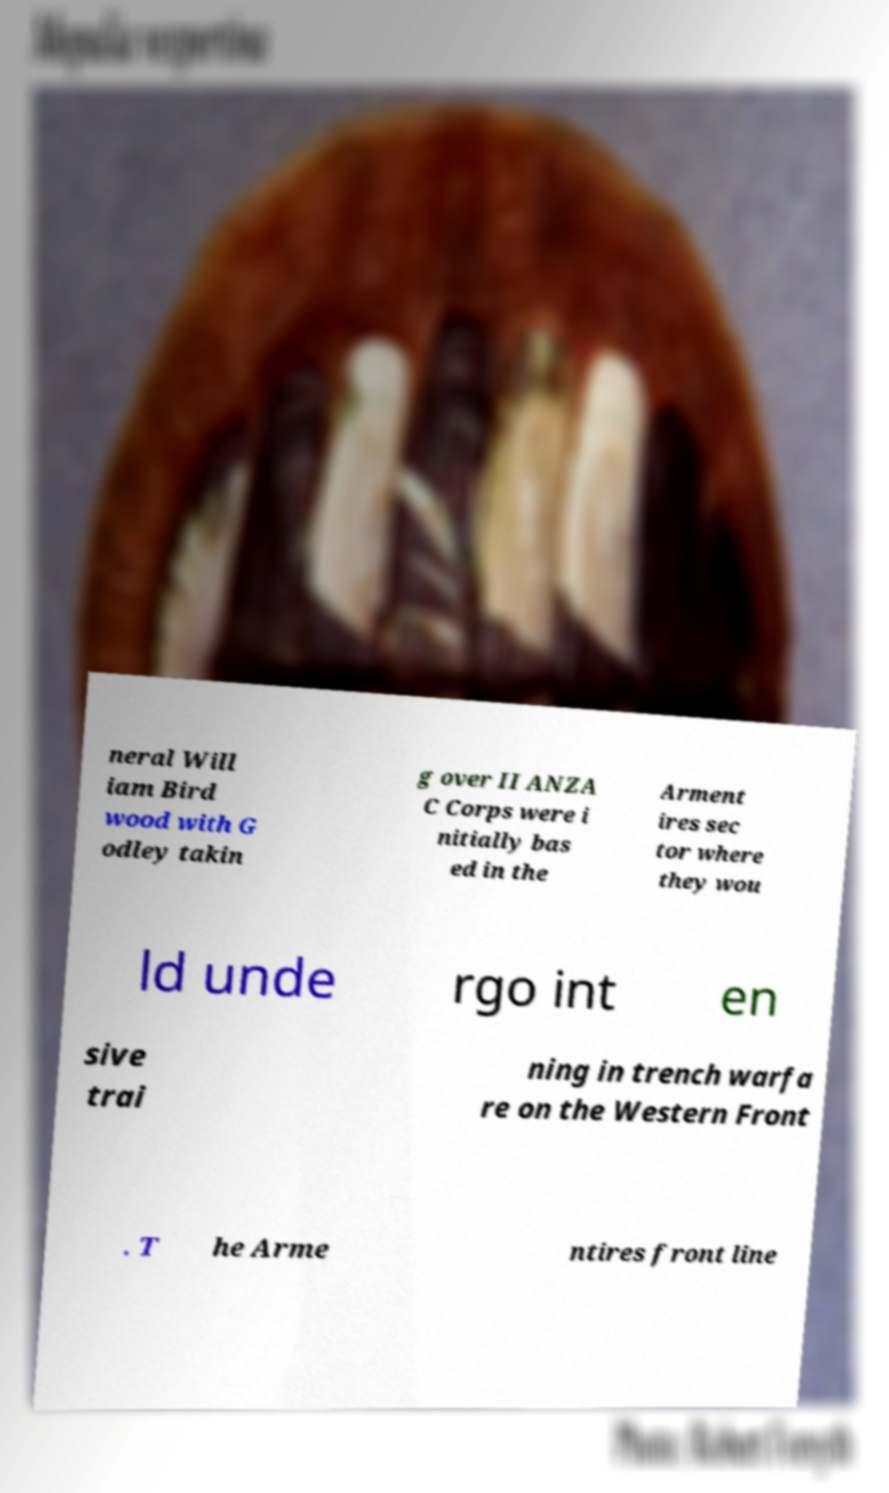Could you extract and type out the text from this image? neral Will iam Bird wood with G odley takin g over II ANZA C Corps were i nitially bas ed in the Arment ires sec tor where they wou ld unde rgo int en sive trai ning in trench warfa re on the Western Front . T he Arme ntires front line 